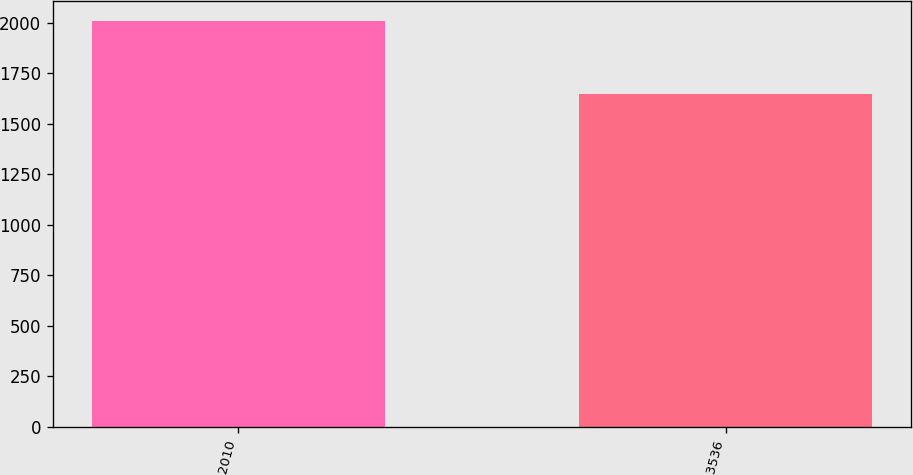Convert chart. <chart><loc_0><loc_0><loc_500><loc_500><bar_chart><fcel>2010<fcel>3536<nl><fcel>2008<fcel>1649<nl></chart> 